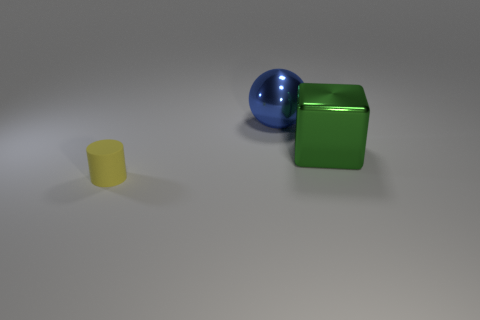Is there anything else that is the same shape as the matte thing?
Give a very brief answer. No. Is there anything else that has the same material as the yellow cylinder?
Offer a terse response. No. What number of objects are left of the large object right of the big metallic thing that is behind the large metal block?
Offer a very short reply. 2. There is a thing that is in front of the big green cube; what is its material?
Your response must be concise. Rubber. The thing that is on the left side of the big block and in front of the big blue metal thing has what shape?
Your answer should be compact. Cylinder. What material is the large ball?
Provide a succinct answer. Metal. How many cylinders are either tiny objects or green objects?
Offer a very short reply. 1. Do the blue object and the large green cube have the same material?
Provide a short and direct response. Yes. There is a thing that is both to the left of the big metal block and in front of the big blue metal object; what material is it?
Your response must be concise. Rubber. Is the number of large blocks that are behind the large metallic ball the same as the number of tiny blue shiny cubes?
Provide a succinct answer. Yes. 